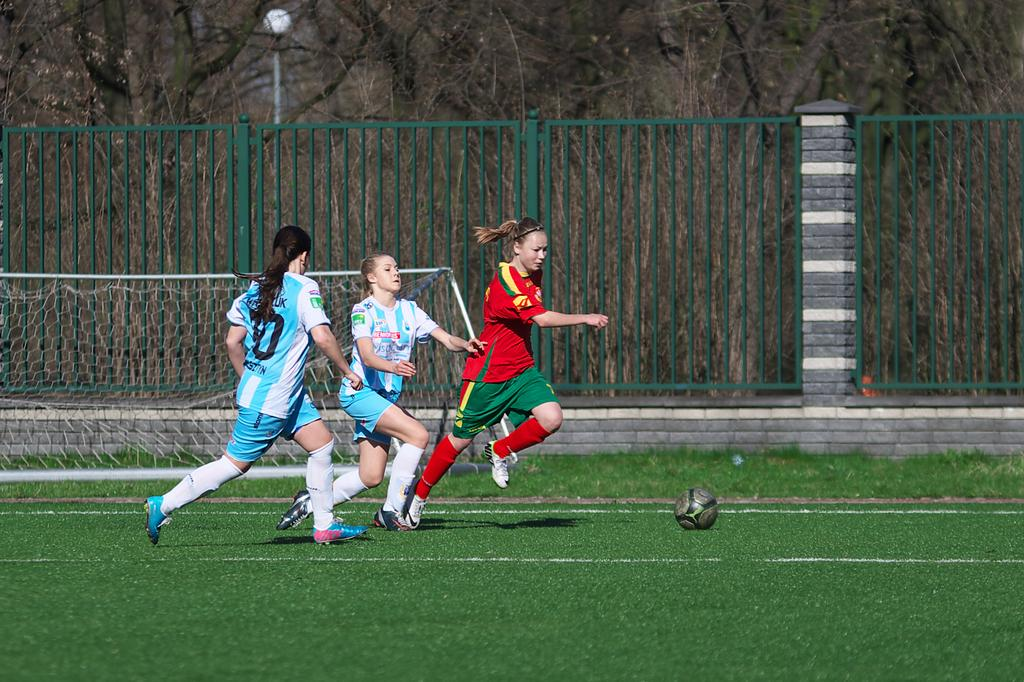Provide a one-sentence caption for the provided image. Three girls on a field going towards a soccer ball with one girl wearing a uniform that has 10 on the back. 